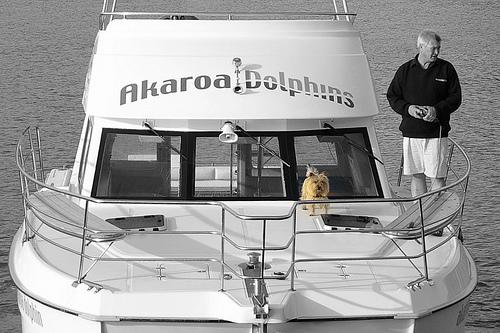Analyze the sentiment displayed in the image, considering the weather and overall atmosphere. The sentiment of the image is calm and peaceful, with cold and grey water setting a relaxing mood on a boat excursion. What kind of boat is depicted in the image? The boat is an Akaroa Dolphins. Describe the visual design and writing on the boat. The boat has "Akaroa Dolphins" written on it and features a clear window and windshield wipers. What is the color of the boat and what is its condition regarding cleanliness? The boat is white and appears to be clean and well-maintained. Can you identify any safety equipment or features on the boat?  There is a siren on the front of the boat and a wooden and metal bench for seating. What type of marine environment is depicted in the image? The image shows a boat sailing on cold, grey water. How would you describe the dog in the image? Mention its color and an accessory it is wearing. The dog is brown and is wearing a black collar. What is the relationship between the man and the dog in the picture? Mention their common context/situation. The man and the dog are both on the boat, possibly enjoying a leisurely boat trip together. Count the number of dogs present in the image. There is one brown dog in the image. Enumerate the colors of the clothes worn by the man in the image. The man is wearing a black shirt or jacket and white shorts. Is the brown dog visibly wearing a red collar in the image? The correct caption mentions a "brown dog wearing a black collar." This instruction is misleading because it suggests the dog is wearing a red collar instead of a black one. Does the boat have green railings on it? The correct caption says "the boat railings is grey." Suggesting that the boat railings are green is misleading because they are actually grey. Are there any cats on the boat? There are no mentions of cats in the image captions; only dogs are mentioned. This instruction is misleading because it suggests the presence of cats when there are none. Is there a blue sofa in the sitting area? The correct caption mentions a "white sofa." This instruction is misleading because it suggests there is a blue sofa instead of a white one. Can you see the orange life jacket on the man wearing white shorts? There is no mention of a life jacket in the image captions. This instruction is misleading because it suggests there's an orange life jacket when there isn't one. Can you see a woman wearing a black jacket in the image? The correct caption says "man wearing a black jacket." This instruction is misleading because it suggests the presence of a woman wearing a black jacket, not a man. 